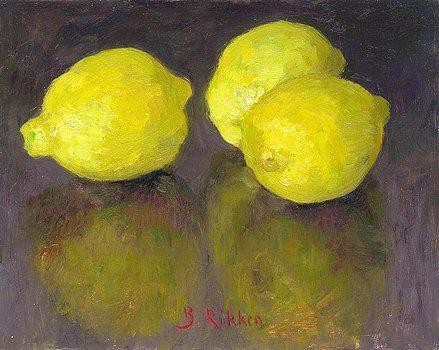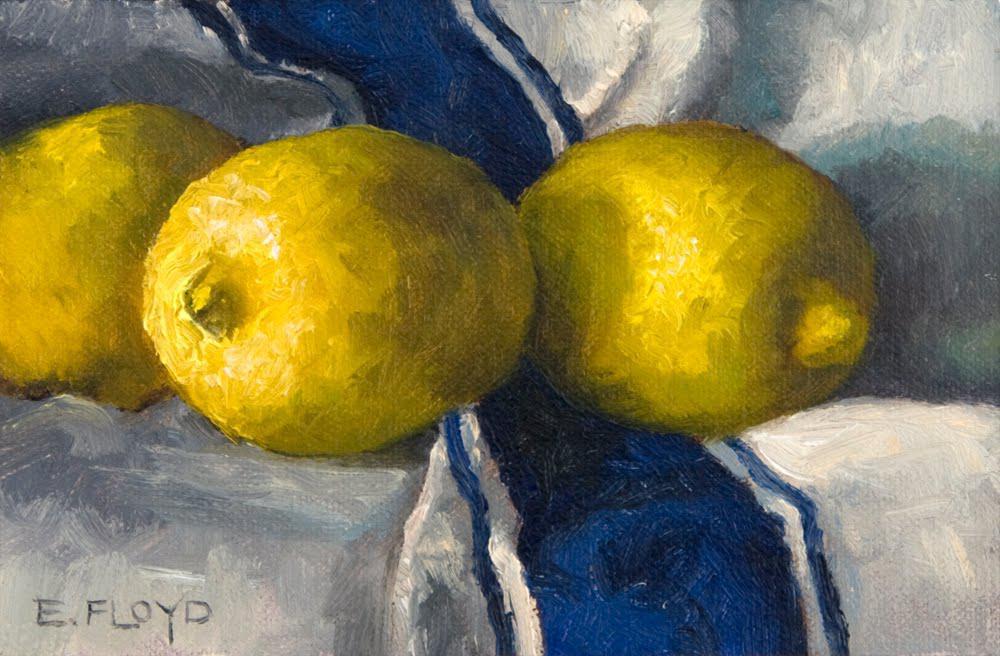The first image is the image on the left, the second image is the image on the right. Given the left and right images, does the statement "Three lemons are laying on a white and blue cloth." hold true? Answer yes or no. Yes. The first image is the image on the left, the second image is the image on the right. For the images displayed, is the sentence "No image includes lemon leaves, and one image shows three whole lemons on white fabric with a blue stripe on it." factually correct? Answer yes or no. Yes. 